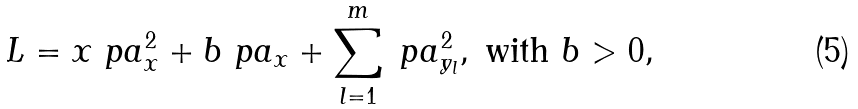Convert formula to latex. <formula><loc_0><loc_0><loc_500><loc_500>L = x \ p a _ { x } ^ { 2 } + b \ p a _ { x } + \sum _ { l = 1 } ^ { m } \ p a _ { y _ { l } } ^ { 2 } , \text { with } b > 0 ,</formula> 